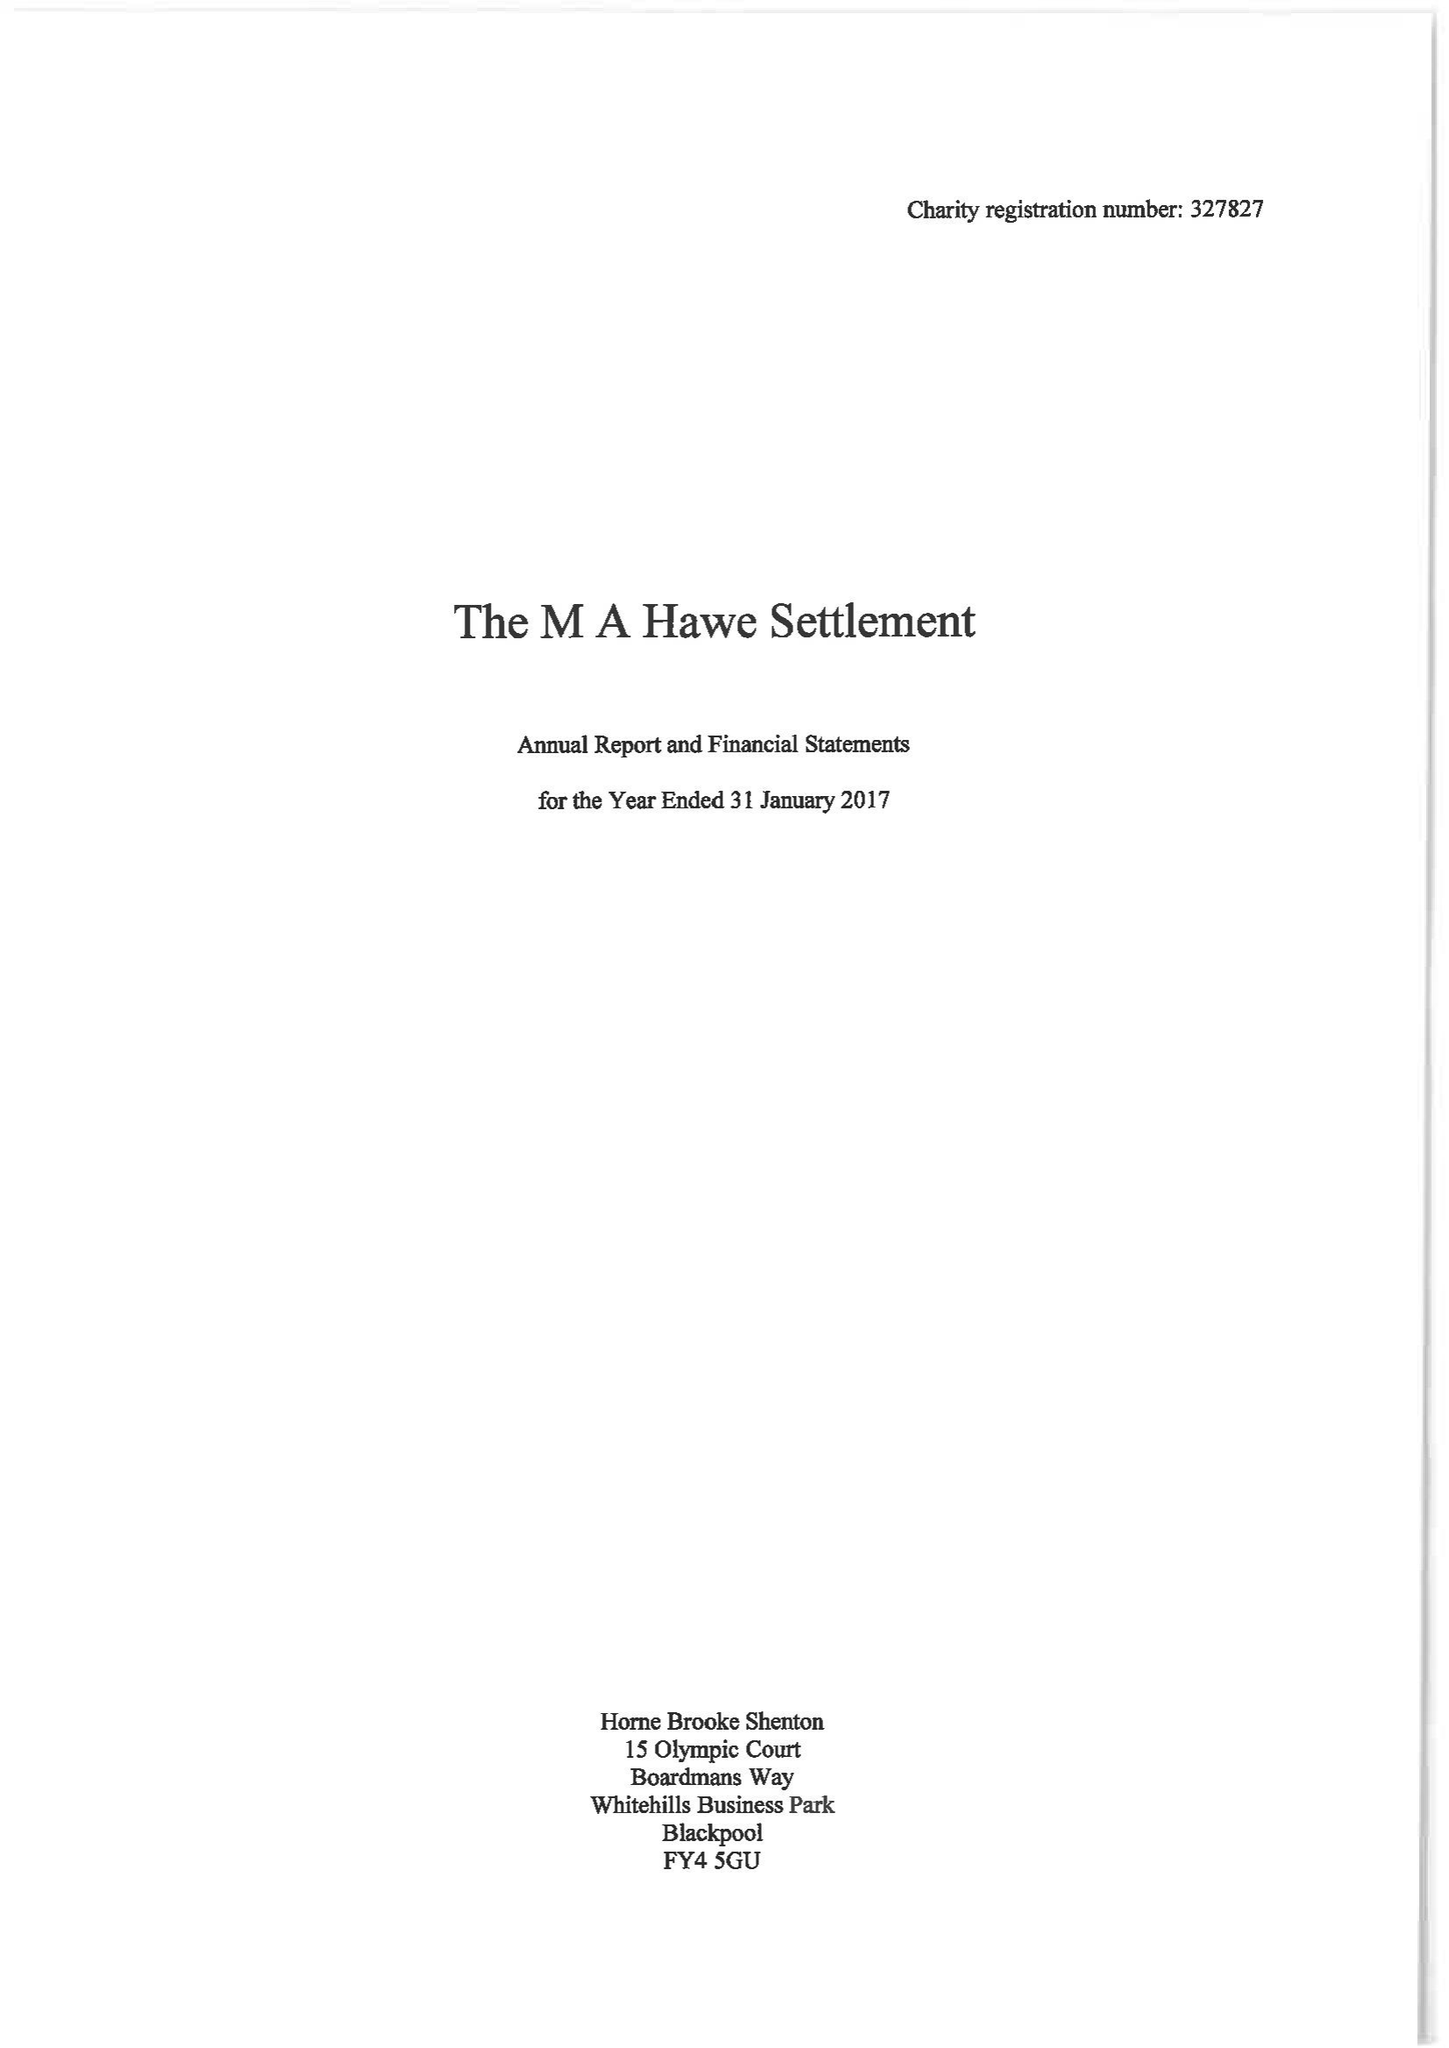What is the value for the report_date?
Answer the question using a single word or phrase. 2017-01-31 